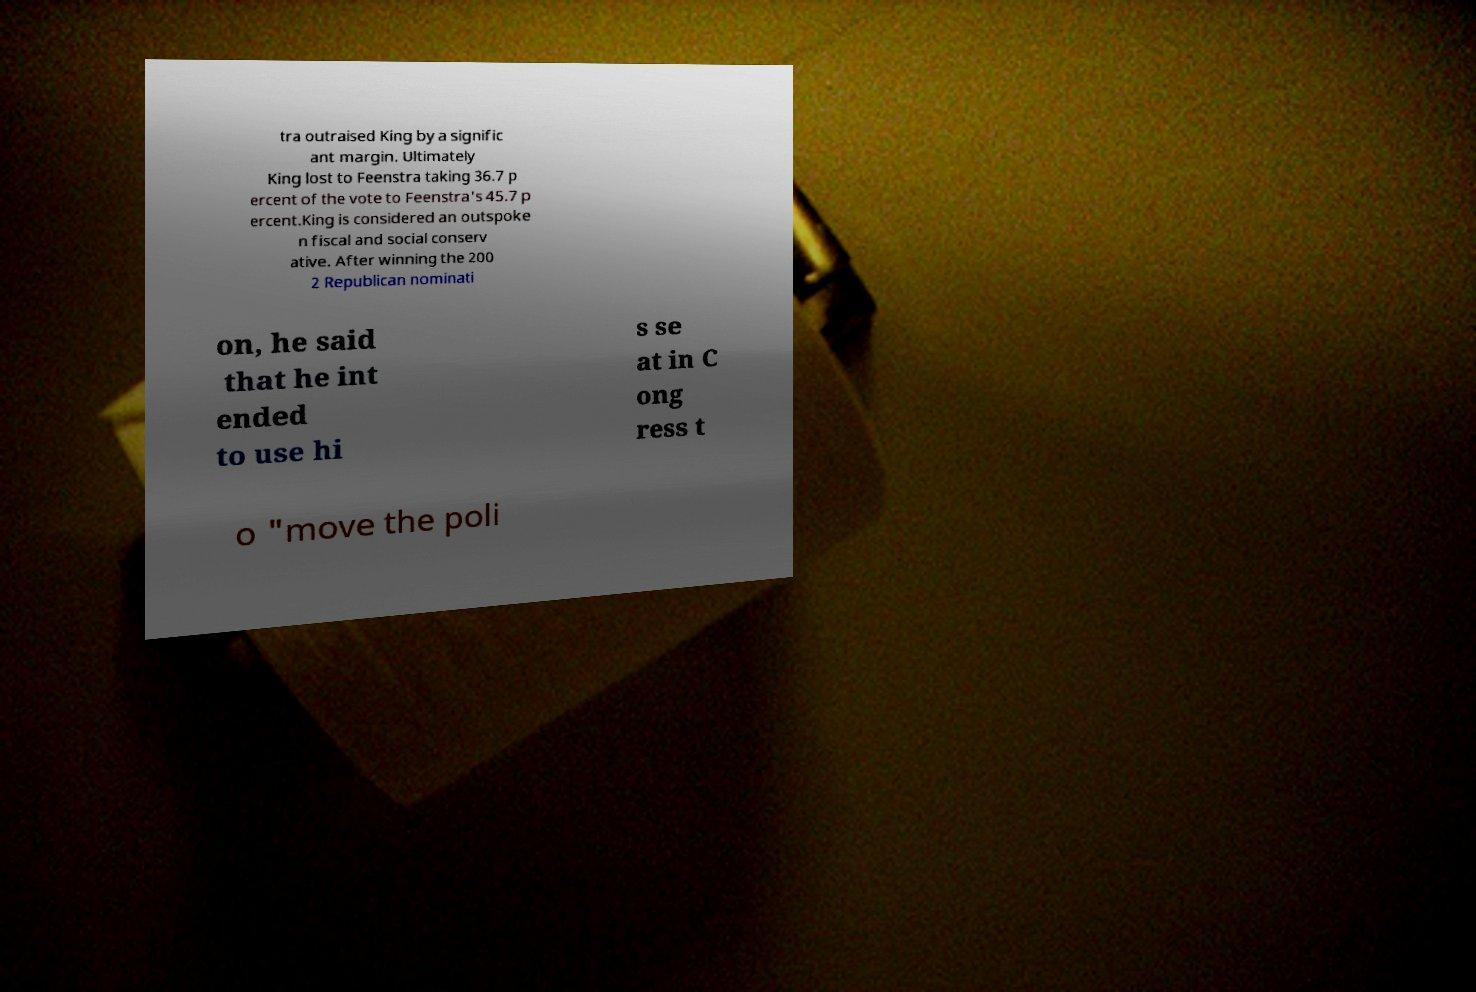What messages or text are displayed in this image? I need them in a readable, typed format. tra outraised King by a signific ant margin. Ultimately King lost to Feenstra taking 36.7 p ercent of the vote to Feenstra's 45.7 p ercent.King is considered an outspoke n fiscal and social conserv ative. After winning the 200 2 Republican nominati on, he said that he int ended to use hi s se at in C ong ress t o "move the poli 